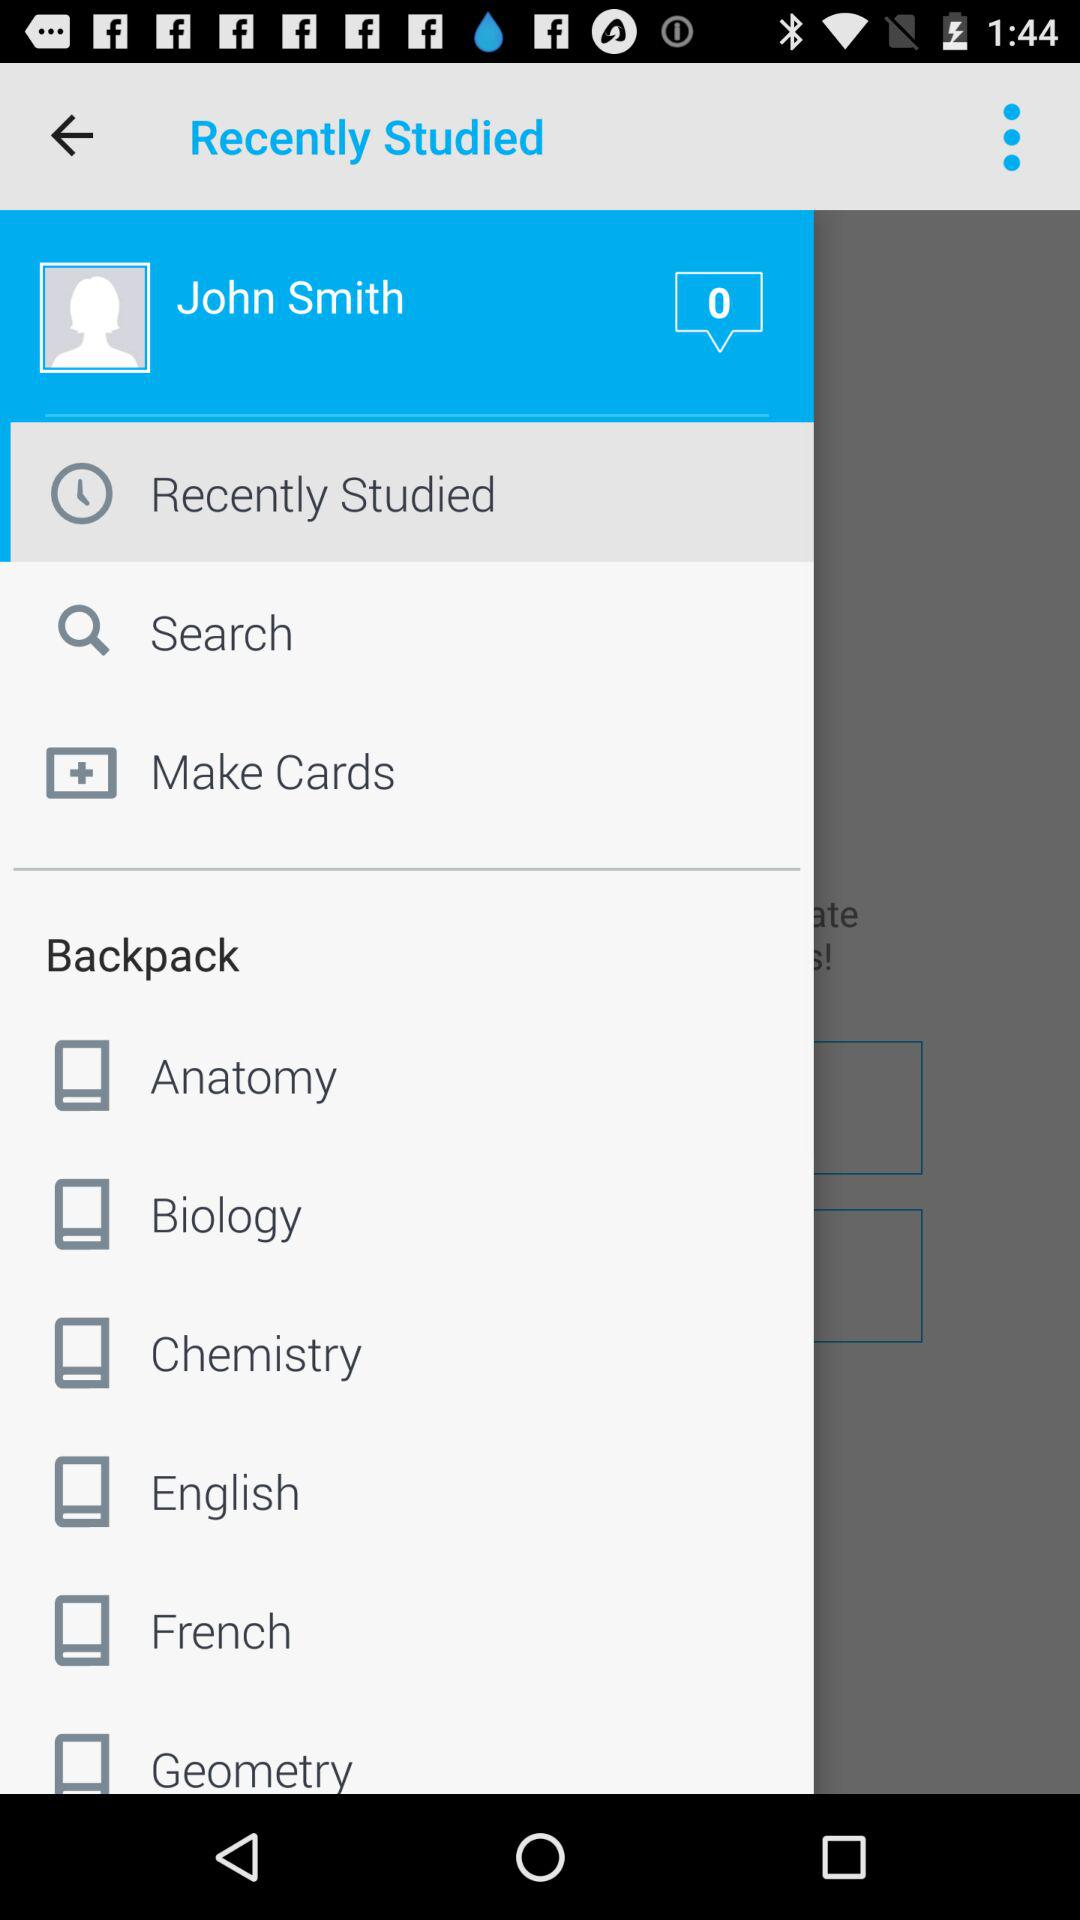What is the user name? The user name is John Smith. 